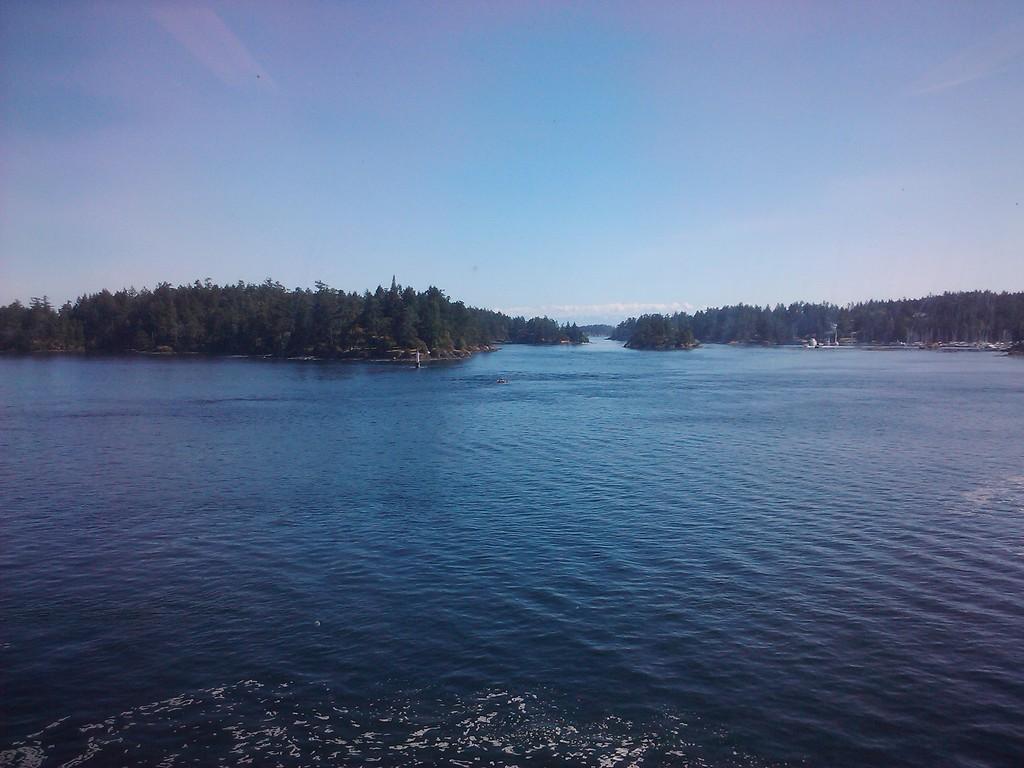Could you give a brief overview of what you see in this image? In this image we can see a river, trees and sky with clouds. 